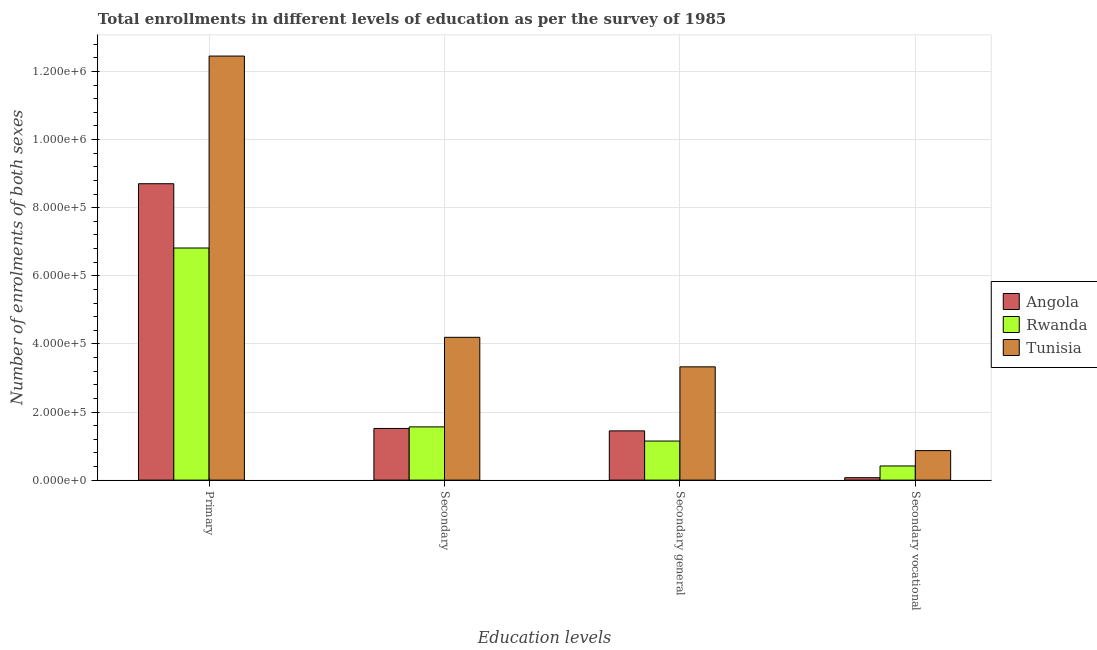How many different coloured bars are there?
Ensure brevity in your answer.  3. How many bars are there on the 3rd tick from the left?
Your answer should be very brief. 3. What is the label of the 3rd group of bars from the left?
Your response must be concise. Secondary general. What is the number of enrolments in secondary general education in Angola?
Your answer should be compact. 1.45e+05. Across all countries, what is the maximum number of enrolments in secondary vocational education?
Make the answer very short. 8.67e+04. Across all countries, what is the minimum number of enrolments in secondary vocational education?
Provide a short and direct response. 7147. In which country was the number of enrolments in secondary vocational education maximum?
Your response must be concise. Tunisia. In which country was the number of enrolments in secondary education minimum?
Make the answer very short. Angola. What is the total number of enrolments in secondary general education in the graph?
Make the answer very short. 5.92e+05. What is the difference between the number of enrolments in secondary general education in Tunisia and that in Rwanda?
Offer a very short reply. 2.18e+05. What is the difference between the number of enrolments in primary education in Tunisia and the number of enrolments in secondary education in Rwanda?
Your answer should be very brief. 1.09e+06. What is the average number of enrolments in secondary general education per country?
Your answer should be compact. 1.97e+05. What is the difference between the number of enrolments in secondary general education and number of enrolments in secondary education in Angola?
Offer a terse response. -7147. What is the ratio of the number of enrolments in secondary education in Tunisia to that in Rwanda?
Your response must be concise. 2.68. Is the number of enrolments in primary education in Angola less than that in Rwanda?
Keep it short and to the point. No. What is the difference between the highest and the second highest number of enrolments in secondary education?
Your answer should be very brief. 2.63e+05. What is the difference between the highest and the lowest number of enrolments in primary education?
Give a very brief answer. 5.64e+05. In how many countries, is the number of enrolments in primary education greater than the average number of enrolments in primary education taken over all countries?
Make the answer very short. 1. What does the 3rd bar from the left in Primary represents?
Your response must be concise. Tunisia. What does the 3rd bar from the right in Secondary general represents?
Offer a very short reply. Angola. Is it the case that in every country, the sum of the number of enrolments in primary education and number of enrolments in secondary education is greater than the number of enrolments in secondary general education?
Offer a very short reply. Yes. How many bars are there?
Offer a very short reply. 12. How many countries are there in the graph?
Give a very brief answer. 3. What is the difference between two consecutive major ticks on the Y-axis?
Your response must be concise. 2.00e+05. Does the graph contain grids?
Offer a terse response. Yes. Where does the legend appear in the graph?
Make the answer very short. Center right. How many legend labels are there?
Give a very brief answer. 3. What is the title of the graph?
Provide a short and direct response. Total enrollments in different levels of education as per the survey of 1985. Does "Oman" appear as one of the legend labels in the graph?
Offer a very short reply. No. What is the label or title of the X-axis?
Ensure brevity in your answer.  Education levels. What is the label or title of the Y-axis?
Give a very brief answer. Number of enrolments of both sexes. What is the Number of enrolments of both sexes of Angola in Primary?
Make the answer very short. 8.70e+05. What is the Number of enrolments of both sexes of Rwanda in Primary?
Give a very brief answer. 6.82e+05. What is the Number of enrolments of both sexes in Tunisia in Primary?
Your response must be concise. 1.25e+06. What is the Number of enrolments of both sexes in Angola in Secondary?
Give a very brief answer. 1.52e+05. What is the Number of enrolments of both sexes of Rwanda in Secondary?
Ensure brevity in your answer.  1.56e+05. What is the Number of enrolments of both sexes of Tunisia in Secondary?
Your answer should be compact. 4.19e+05. What is the Number of enrolments of both sexes in Angola in Secondary general?
Give a very brief answer. 1.45e+05. What is the Number of enrolments of both sexes of Rwanda in Secondary general?
Your response must be concise. 1.15e+05. What is the Number of enrolments of both sexes of Tunisia in Secondary general?
Ensure brevity in your answer.  3.33e+05. What is the Number of enrolments of both sexes in Angola in Secondary vocational?
Your response must be concise. 7147. What is the Number of enrolments of both sexes in Rwanda in Secondary vocational?
Your response must be concise. 4.16e+04. What is the Number of enrolments of both sexes of Tunisia in Secondary vocational?
Provide a short and direct response. 8.67e+04. Across all Education levels, what is the maximum Number of enrolments of both sexes of Angola?
Offer a terse response. 8.70e+05. Across all Education levels, what is the maximum Number of enrolments of both sexes in Rwanda?
Keep it short and to the point. 6.82e+05. Across all Education levels, what is the maximum Number of enrolments of both sexes of Tunisia?
Your answer should be compact. 1.25e+06. Across all Education levels, what is the minimum Number of enrolments of both sexes in Angola?
Provide a short and direct response. 7147. Across all Education levels, what is the minimum Number of enrolments of both sexes of Rwanda?
Offer a terse response. 4.16e+04. Across all Education levels, what is the minimum Number of enrolments of both sexes in Tunisia?
Your answer should be very brief. 8.67e+04. What is the total Number of enrolments of both sexes in Angola in the graph?
Your response must be concise. 1.17e+06. What is the total Number of enrolments of both sexes in Rwanda in the graph?
Offer a very short reply. 9.94e+05. What is the total Number of enrolments of both sexes in Tunisia in the graph?
Make the answer very short. 2.08e+06. What is the difference between the Number of enrolments of both sexes of Angola in Primary and that in Secondary?
Your answer should be very brief. 7.19e+05. What is the difference between the Number of enrolments of both sexes of Rwanda in Primary and that in Secondary?
Ensure brevity in your answer.  5.25e+05. What is the difference between the Number of enrolments of both sexes in Tunisia in Primary and that in Secondary?
Make the answer very short. 8.26e+05. What is the difference between the Number of enrolments of both sexes of Angola in Primary and that in Secondary general?
Provide a succinct answer. 7.26e+05. What is the difference between the Number of enrolments of both sexes of Rwanda in Primary and that in Secondary general?
Offer a very short reply. 5.67e+05. What is the difference between the Number of enrolments of both sexes of Tunisia in Primary and that in Secondary general?
Your response must be concise. 9.13e+05. What is the difference between the Number of enrolments of both sexes in Angola in Primary and that in Secondary vocational?
Your answer should be compact. 8.63e+05. What is the difference between the Number of enrolments of both sexes of Rwanda in Primary and that in Secondary vocational?
Ensure brevity in your answer.  6.40e+05. What is the difference between the Number of enrolments of both sexes in Tunisia in Primary and that in Secondary vocational?
Your answer should be very brief. 1.16e+06. What is the difference between the Number of enrolments of both sexes of Angola in Secondary and that in Secondary general?
Provide a short and direct response. 7147. What is the difference between the Number of enrolments of both sexes in Rwanda in Secondary and that in Secondary general?
Give a very brief answer. 4.16e+04. What is the difference between the Number of enrolments of both sexes of Tunisia in Secondary and that in Secondary general?
Make the answer very short. 8.67e+04. What is the difference between the Number of enrolments of both sexes of Angola in Secondary and that in Secondary vocational?
Offer a terse response. 1.45e+05. What is the difference between the Number of enrolments of both sexes of Rwanda in Secondary and that in Secondary vocational?
Your response must be concise. 1.15e+05. What is the difference between the Number of enrolments of both sexes of Tunisia in Secondary and that in Secondary vocational?
Offer a very short reply. 3.33e+05. What is the difference between the Number of enrolments of both sexes of Angola in Secondary general and that in Secondary vocational?
Keep it short and to the point. 1.37e+05. What is the difference between the Number of enrolments of both sexes in Rwanda in Secondary general and that in Secondary vocational?
Offer a very short reply. 7.32e+04. What is the difference between the Number of enrolments of both sexes in Tunisia in Secondary general and that in Secondary vocational?
Offer a terse response. 2.46e+05. What is the difference between the Number of enrolments of both sexes of Angola in Primary and the Number of enrolments of both sexes of Rwanda in Secondary?
Your response must be concise. 7.14e+05. What is the difference between the Number of enrolments of both sexes of Angola in Primary and the Number of enrolments of both sexes of Tunisia in Secondary?
Your answer should be compact. 4.51e+05. What is the difference between the Number of enrolments of both sexes in Rwanda in Primary and the Number of enrolments of both sexes in Tunisia in Secondary?
Your answer should be very brief. 2.62e+05. What is the difference between the Number of enrolments of both sexes of Angola in Primary and the Number of enrolments of both sexes of Rwanda in Secondary general?
Offer a very short reply. 7.56e+05. What is the difference between the Number of enrolments of both sexes of Angola in Primary and the Number of enrolments of both sexes of Tunisia in Secondary general?
Ensure brevity in your answer.  5.38e+05. What is the difference between the Number of enrolments of both sexes of Rwanda in Primary and the Number of enrolments of both sexes of Tunisia in Secondary general?
Provide a succinct answer. 3.49e+05. What is the difference between the Number of enrolments of both sexes of Angola in Primary and the Number of enrolments of both sexes of Rwanda in Secondary vocational?
Your response must be concise. 8.29e+05. What is the difference between the Number of enrolments of both sexes of Angola in Primary and the Number of enrolments of both sexes of Tunisia in Secondary vocational?
Your answer should be very brief. 7.84e+05. What is the difference between the Number of enrolments of both sexes in Rwanda in Primary and the Number of enrolments of both sexes in Tunisia in Secondary vocational?
Provide a short and direct response. 5.95e+05. What is the difference between the Number of enrolments of both sexes in Angola in Secondary and the Number of enrolments of both sexes in Rwanda in Secondary general?
Keep it short and to the point. 3.70e+04. What is the difference between the Number of enrolments of both sexes in Angola in Secondary and the Number of enrolments of both sexes in Tunisia in Secondary general?
Offer a very short reply. -1.81e+05. What is the difference between the Number of enrolments of both sexes in Rwanda in Secondary and the Number of enrolments of both sexes in Tunisia in Secondary general?
Give a very brief answer. -1.76e+05. What is the difference between the Number of enrolments of both sexes of Angola in Secondary and the Number of enrolments of both sexes of Rwanda in Secondary vocational?
Make the answer very short. 1.10e+05. What is the difference between the Number of enrolments of both sexes of Angola in Secondary and the Number of enrolments of both sexes of Tunisia in Secondary vocational?
Your answer should be compact. 6.51e+04. What is the difference between the Number of enrolments of both sexes of Rwanda in Secondary and the Number of enrolments of both sexes of Tunisia in Secondary vocational?
Offer a terse response. 6.97e+04. What is the difference between the Number of enrolments of both sexes of Angola in Secondary general and the Number of enrolments of both sexes of Rwanda in Secondary vocational?
Offer a very short reply. 1.03e+05. What is the difference between the Number of enrolments of both sexes in Angola in Secondary general and the Number of enrolments of both sexes in Tunisia in Secondary vocational?
Provide a succinct answer. 5.80e+04. What is the difference between the Number of enrolments of both sexes in Rwanda in Secondary general and the Number of enrolments of both sexes in Tunisia in Secondary vocational?
Your answer should be compact. 2.81e+04. What is the average Number of enrolments of both sexes in Angola per Education levels?
Keep it short and to the point. 2.93e+05. What is the average Number of enrolments of both sexes in Rwanda per Education levels?
Keep it short and to the point. 2.49e+05. What is the average Number of enrolments of both sexes in Tunisia per Education levels?
Make the answer very short. 5.21e+05. What is the difference between the Number of enrolments of both sexes of Angola and Number of enrolments of both sexes of Rwanda in Primary?
Offer a very short reply. 1.89e+05. What is the difference between the Number of enrolments of both sexes of Angola and Number of enrolments of both sexes of Tunisia in Primary?
Give a very brief answer. -3.75e+05. What is the difference between the Number of enrolments of both sexes in Rwanda and Number of enrolments of both sexes in Tunisia in Primary?
Offer a very short reply. -5.64e+05. What is the difference between the Number of enrolments of both sexes of Angola and Number of enrolments of both sexes of Rwanda in Secondary?
Offer a very short reply. -4588. What is the difference between the Number of enrolments of both sexes in Angola and Number of enrolments of both sexes in Tunisia in Secondary?
Give a very brief answer. -2.68e+05. What is the difference between the Number of enrolments of both sexes in Rwanda and Number of enrolments of both sexes in Tunisia in Secondary?
Provide a succinct answer. -2.63e+05. What is the difference between the Number of enrolments of both sexes in Angola and Number of enrolments of both sexes in Rwanda in Secondary general?
Offer a very short reply. 2.98e+04. What is the difference between the Number of enrolments of both sexes in Angola and Number of enrolments of both sexes in Tunisia in Secondary general?
Your answer should be very brief. -1.88e+05. What is the difference between the Number of enrolments of both sexes in Rwanda and Number of enrolments of both sexes in Tunisia in Secondary general?
Offer a very short reply. -2.18e+05. What is the difference between the Number of enrolments of both sexes of Angola and Number of enrolments of both sexes of Rwanda in Secondary vocational?
Offer a terse response. -3.44e+04. What is the difference between the Number of enrolments of both sexes in Angola and Number of enrolments of both sexes in Tunisia in Secondary vocational?
Provide a short and direct response. -7.95e+04. What is the difference between the Number of enrolments of both sexes of Rwanda and Number of enrolments of both sexes of Tunisia in Secondary vocational?
Give a very brief answer. -4.51e+04. What is the ratio of the Number of enrolments of both sexes in Angola in Primary to that in Secondary?
Offer a terse response. 5.74. What is the ratio of the Number of enrolments of both sexes of Rwanda in Primary to that in Secondary?
Your answer should be very brief. 4.36. What is the ratio of the Number of enrolments of both sexes in Tunisia in Primary to that in Secondary?
Offer a terse response. 2.97. What is the ratio of the Number of enrolments of both sexes of Angola in Primary to that in Secondary general?
Offer a terse response. 6.02. What is the ratio of the Number of enrolments of both sexes in Rwanda in Primary to that in Secondary general?
Keep it short and to the point. 5.94. What is the ratio of the Number of enrolments of both sexes in Tunisia in Primary to that in Secondary general?
Offer a terse response. 3.74. What is the ratio of the Number of enrolments of both sexes of Angola in Primary to that in Secondary vocational?
Your answer should be very brief. 121.79. What is the ratio of the Number of enrolments of both sexes of Rwanda in Primary to that in Secondary vocational?
Your answer should be compact. 16.39. What is the ratio of the Number of enrolments of both sexes in Tunisia in Primary to that in Secondary vocational?
Your answer should be compact. 14.37. What is the ratio of the Number of enrolments of both sexes in Angola in Secondary to that in Secondary general?
Ensure brevity in your answer.  1.05. What is the ratio of the Number of enrolments of both sexes in Rwanda in Secondary to that in Secondary general?
Ensure brevity in your answer.  1.36. What is the ratio of the Number of enrolments of both sexes in Tunisia in Secondary to that in Secondary general?
Your answer should be very brief. 1.26. What is the ratio of the Number of enrolments of both sexes in Angola in Secondary to that in Secondary vocational?
Provide a short and direct response. 21.23. What is the ratio of the Number of enrolments of both sexes in Rwanda in Secondary to that in Secondary vocational?
Make the answer very short. 3.76. What is the ratio of the Number of enrolments of both sexes of Tunisia in Secondary to that in Secondary vocational?
Your response must be concise. 4.84. What is the ratio of the Number of enrolments of both sexes in Angola in Secondary general to that in Secondary vocational?
Ensure brevity in your answer.  20.23. What is the ratio of the Number of enrolments of both sexes in Rwanda in Secondary general to that in Secondary vocational?
Keep it short and to the point. 2.76. What is the ratio of the Number of enrolments of both sexes of Tunisia in Secondary general to that in Secondary vocational?
Your response must be concise. 3.84. What is the difference between the highest and the second highest Number of enrolments of both sexes of Angola?
Provide a short and direct response. 7.19e+05. What is the difference between the highest and the second highest Number of enrolments of both sexes in Rwanda?
Offer a terse response. 5.25e+05. What is the difference between the highest and the second highest Number of enrolments of both sexes in Tunisia?
Make the answer very short. 8.26e+05. What is the difference between the highest and the lowest Number of enrolments of both sexes in Angola?
Your answer should be very brief. 8.63e+05. What is the difference between the highest and the lowest Number of enrolments of both sexes of Rwanda?
Your answer should be very brief. 6.40e+05. What is the difference between the highest and the lowest Number of enrolments of both sexes in Tunisia?
Give a very brief answer. 1.16e+06. 